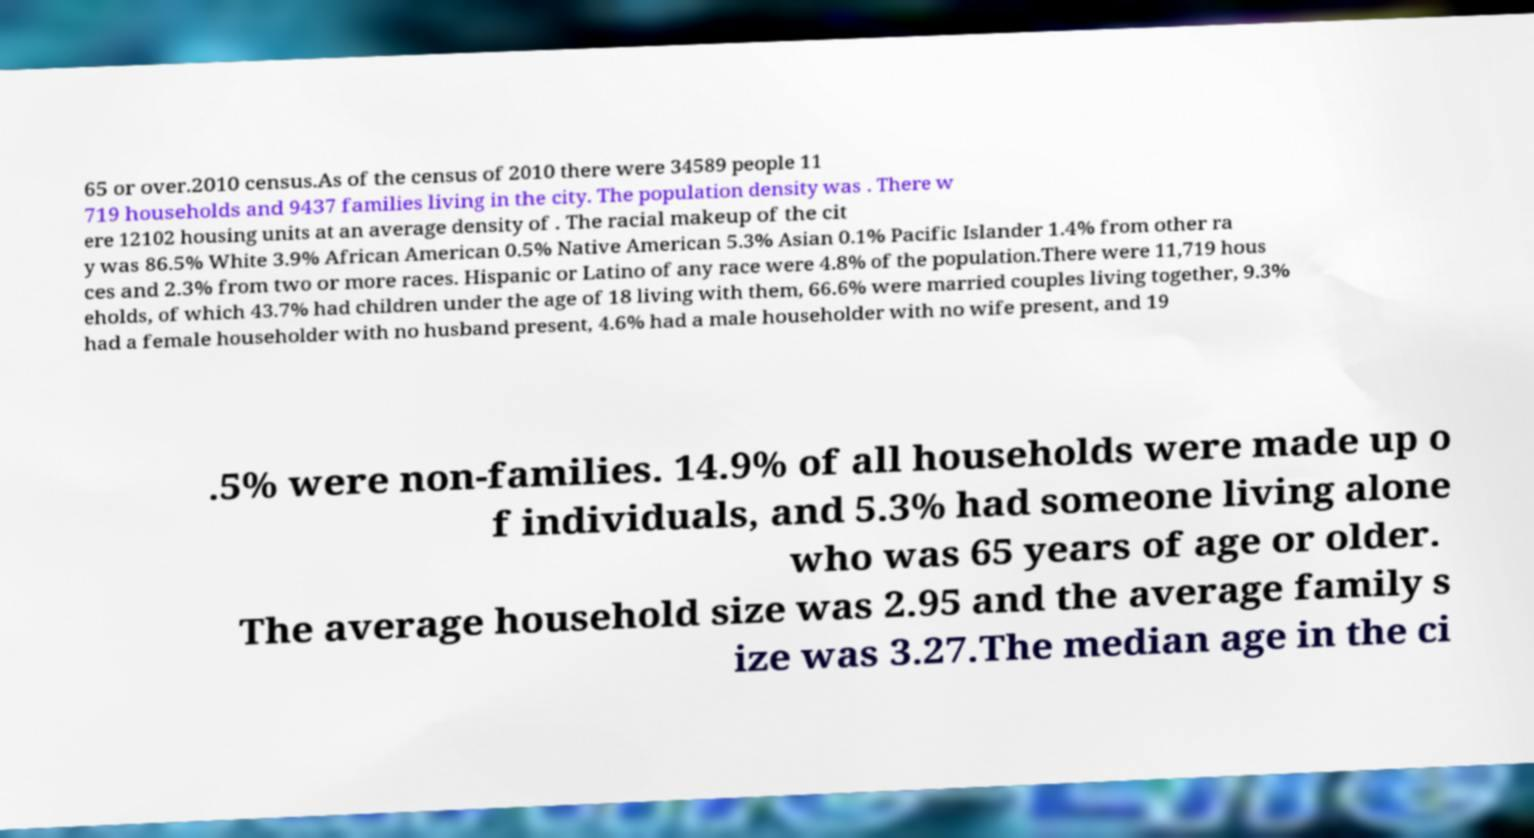I need the written content from this picture converted into text. Can you do that? 65 or over.2010 census.As of the census of 2010 there were 34589 people 11 719 households and 9437 families living in the city. The population density was . There w ere 12102 housing units at an average density of . The racial makeup of the cit y was 86.5% White 3.9% African American 0.5% Native American 5.3% Asian 0.1% Pacific Islander 1.4% from other ra ces and 2.3% from two or more races. Hispanic or Latino of any race were 4.8% of the population.There were 11,719 hous eholds, of which 43.7% had children under the age of 18 living with them, 66.6% were married couples living together, 9.3% had a female householder with no husband present, 4.6% had a male householder with no wife present, and 19 .5% were non-families. 14.9% of all households were made up o f individuals, and 5.3% had someone living alone who was 65 years of age or older. The average household size was 2.95 and the average family s ize was 3.27.The median age in the ci 